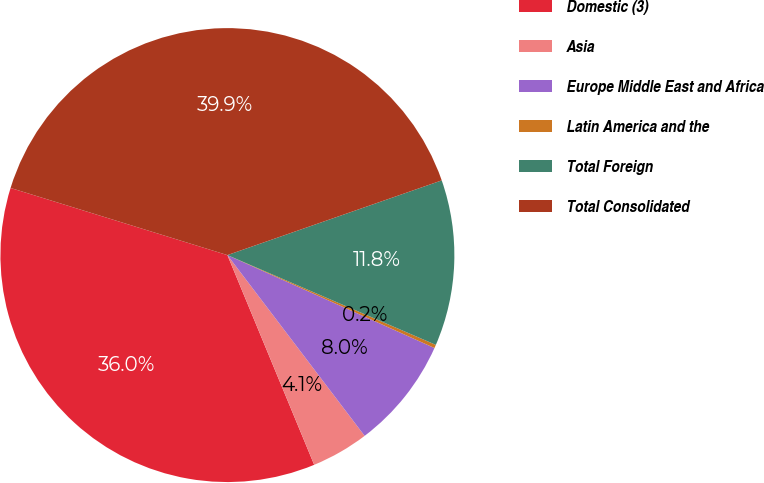Convert chart to OTSL. <chart><loc_0><loc_0><loc_500><loc_500><pie_chart><fcel>Domestic (3)<fcel>Asia<fcel>Europe Middle East and Africa<fcel>Latin America and the<fcel>Total Foreign<fcel>Total Consolidated<nl><fcel>36.02%<fcel>4.09%<fcel>7.95%<fcel>0.24%<fcel>11.81%<fcel>39.88%<nl></chart> 